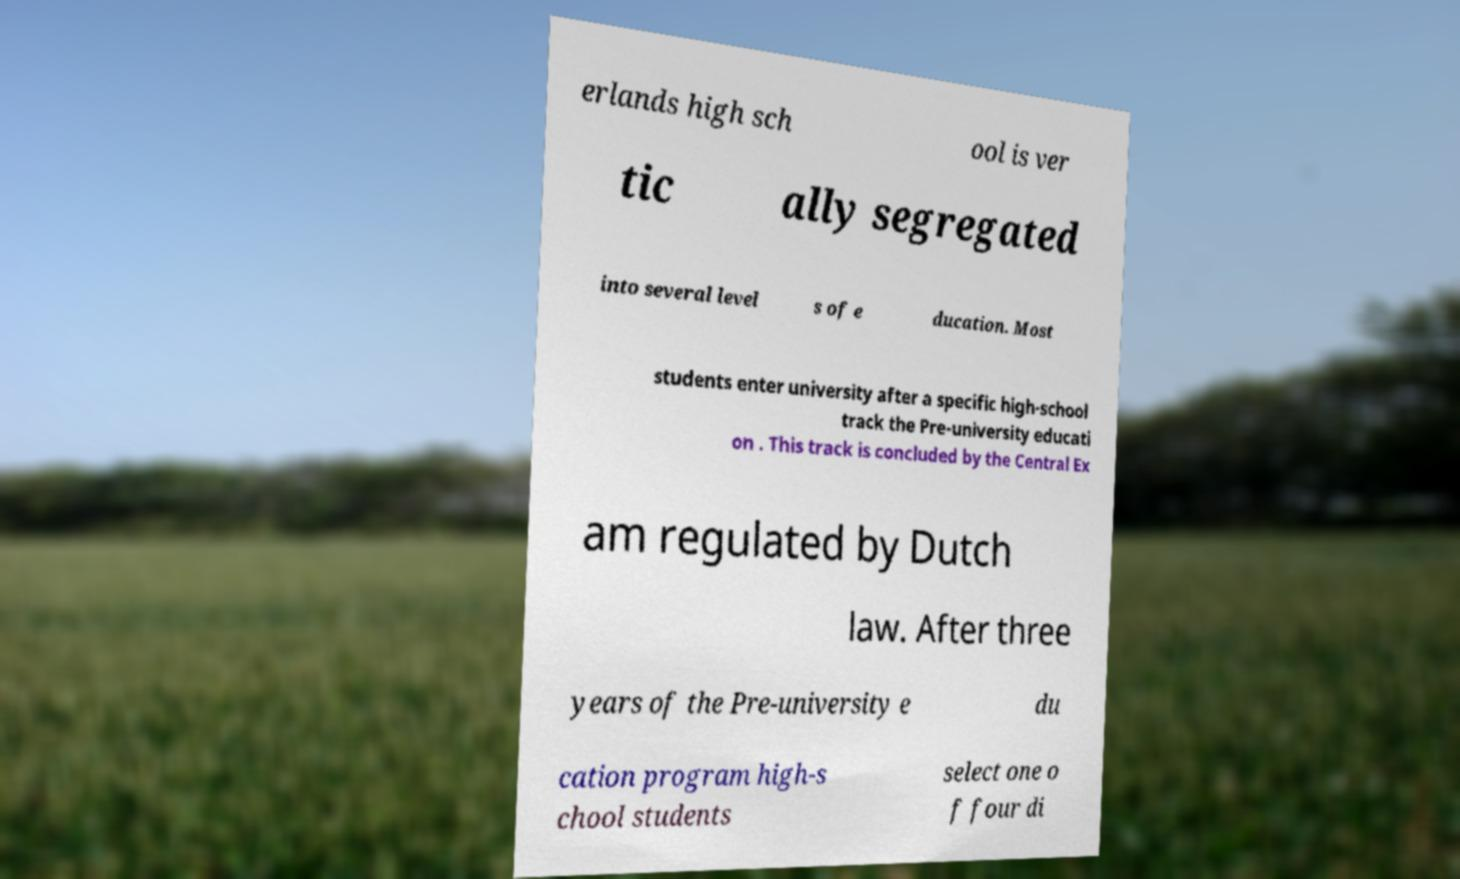For documentation purposes, I need the text within this image transcribed. Could you provide that? erlands high sch ool is ver tic ally segregated into several level s of e ducation. Most students enter university after a specific high-school track the Pre-university educati on . This track is concluded by the Central Ex am regulated by Dutch law. After three years of the Pre-university e du cation program high-s chool students select one o f four di 